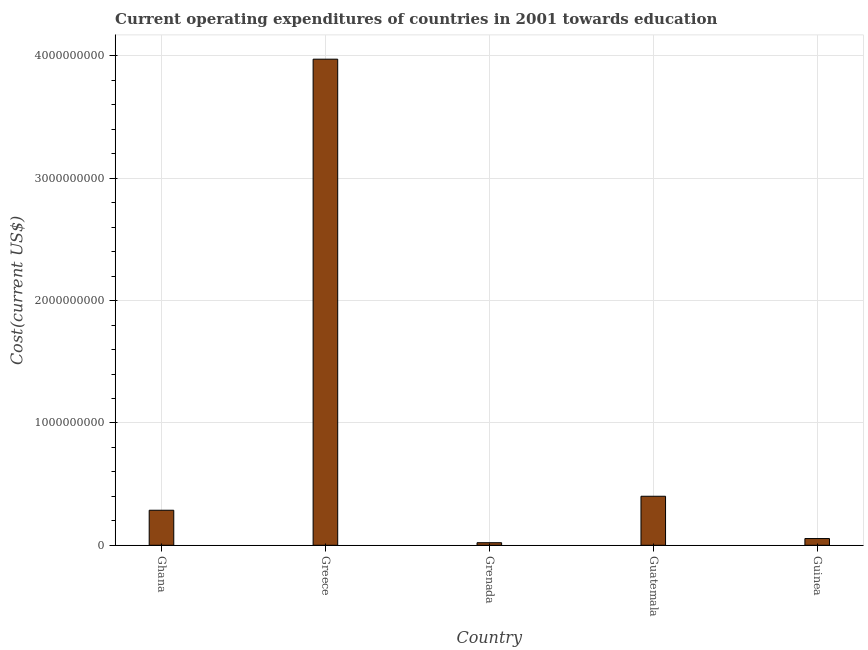Does the graph contain any zero values?
Your answer should be compact. No. Does the graph contain grids?
Your answer should be compact. Yes. What is the title of the graph?
Ensure brevity in your answer.  Current operating expenditures of countries in 2001 towards education. What is the label or title of the X-axis?
Keep it short and to the point. Country. What is the label or title of the Y-axis?
Offer a very short reply. Cost(current US$). What is the education expenditure in Guinea?
Your answer should be compact. 5.49e+07. Across all countries, what is the maximum education expenditure?
Offer a terse response. 3.97e+09. Across all countries, what is the minimum education expenditure?
Make the answer very short. 2.10e+07. In which country was the education expenditure minimum?
Offer a terse response. Grenada. What is the sum of the education expenditure?
Give a very brief answer. 4.74e+09. What is the difference between the education expenditure in Grenada and Guinea?
Your answer should be compact. -3.39e+07. What is the average education expenditure per country?
Your response must be concise. 9.47e+08. What is the median education expenditure?
Offer a terse response. 2.86e+08. In how many countries, is the education expenditure greater than 600000000 US$?
Offer a very short reply. 1. What is the ratio of the education expenditure in Grenada to that in Guatemala?
Your answer should be very brief. 0.05. Is the difference between the education expenditure in Ghana and Guatemala greater than the difference between any two countries?
Ensure brevity in your answer.  No. What is the difference between the highest and the second highest education expenditure?
Your response must be concise. 3.57e+09. Is the sum of the education expenditure in Ghana and Guatemala greater than the maximum education expenditure across all countries?
Provide a short and direct response. No. What is the difference between the highest and the lowest education expenditure?
Make the answer very short. 3.95e+09. How many bars are there?
Offer a very short reply. 5. How many countries are there in the graph?
Offer a very short reply. 5. What is the difference between two consecutive major ticks on the Y-axis?
Your answer should be very brief. 1.00e+09. Are the values on the major ticks of Y-axis written in scientific E-notation?
Your answer should be very brief. No. What is the Cost(current US$) in Ghana?
Your response must be concise. 2.86e+08. What is the Cost(current US$) in Greece?
Ensure brevity in your answer.  3.97e+09. What is the Cost(current US$) in Grenada?
Ensure brevity in your answer.  2.10e+07. What is the Cost(current US$) of Guatemala?
Your answer should be compact. 4.01e+08. What is the Cost(current US$) in Guinea?
Make the answer very short. 5.49e+07. What is the difference between the Cost(current US$) in Ghana and Greece?
Your answer should be compact. -3.69e+09. What is the difference between the Cost(current US$) in Ghana and Grenada?
Provide a succinct answer. 2.65e+08. What is the difference between the Cost(current US$) in Ghana and Guatemala?
Provide a short and direct response. -1.14e+08. What is the difference between the Cost(current US$) in Ghana and Guinea?
Provide a succinct answer. 2.31e+08. What is the difference between the Cost(current US$) in Greece and Grenada?
Ensure brevity in your answer.  3.95e+09. What is the difference between the Cost(current US$) in Greece and Guatemala?
Your answer should be very brief. 3.57e+09. What is the difference between the Cost(current US$) in Greece and Guinea?
Your answer should be compact. 3.92e+09. What is the difference between the Cost(current US$) in Grenada and Guatemala?
Give a very brief answer. -3.80e+08. What is the difference between the Cost(current US$) in Grenada and Guinea?
Your answer should be compact. -3.39e+07. What is the difference between the Cost(current US$) in Guatemala and Guinea?
Provide a short and direct response. 3.46e+08. What is the ratio of the Cost(current US$) in Ghana to that in Greece?
Keep it short and to the point. 0.07. What is the ratio of the Cost(current US$) in Ghana to that in Grenada?
Provide a succinct answer. 13.65. What is the ratio of the Cost(current US$) in Ghana to that in Guatemala?
Make the answer very short. 0.71. What is the ratio of the Cost(current US$) in Ghana to that in Guinea?
Keep it short and to the point. 5.21. What is the ratio of the Cost(current US$) in Greece to that in Grenada?
Offer a terse response. 189.4. What is the ratio of the Cost(current US$) in Greece to that in Guatemala?
Your response must be concise. 9.92. What is the ratio of the Cost(current US$) in Greece to that in Guinea?
Give a very brief answer. 72.34. What is the ratio of the Cost(current US$) in Grenada to that in Guatemala?
Keep it short and to the point. 0.05. What is the ratio of the Cost(current US$) in Grenada to that in Guinea?
Provide a succinct answer. 0.38. What is the ratio of the Cost(current US$) in Guatemala to that in Guinea?
Keep it short and to the point. 7.29. 